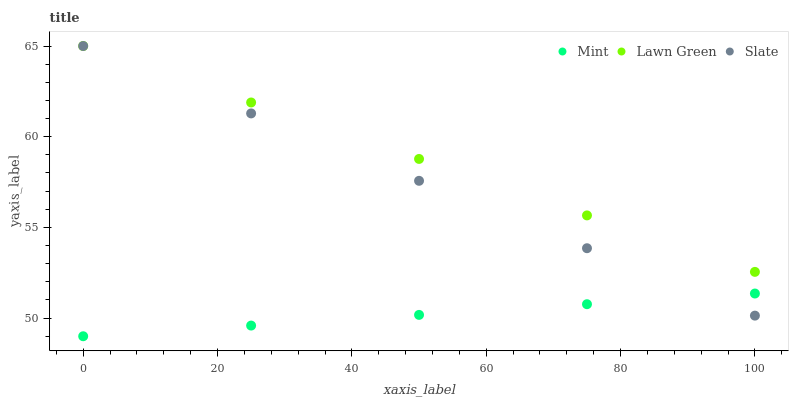Does Mint have the minimum area under the curve?
Answer yes or no. Yes. Does Lawn Green have the maximum area under the curve?
Answer yes or no. Yes. Does Slate have the minimum area under the curve?
Answer yes or no. No. Does Slate have the maximum area under the curve?
Answer yes or no. No. Is Lawn Green the smoothest?
Answer yes or no. Yes. Is Mint the roughest?
Answer yes or no. Yes. Is Slate the smoothest?
Answer yes or no. No. Is Slate the roughest?
Answer yes or no. No. Does Mint have the lowest value?
Answer yes or no. Yes. Does Slate have the lowest value?
Answer yes or no. No. Does Slate have the highest value?
Answer yes or no. Yes. Does Mint have the highest value?
Answer yes or no. No. Is Mint less than Lawn Green?
Answer yes or no. Yes. Is Lawn Green greater than Mint?
Answer yes or no. Yes. Does Mint intersect Slate?
Answer yes or no. Yes. Is Mint less than Slate?
Answer yes or no. No. Is Mint greater than Slate?
Answer yes or no. No. Does Mint intersect Lawn Green?
Answer yes or no. No. 